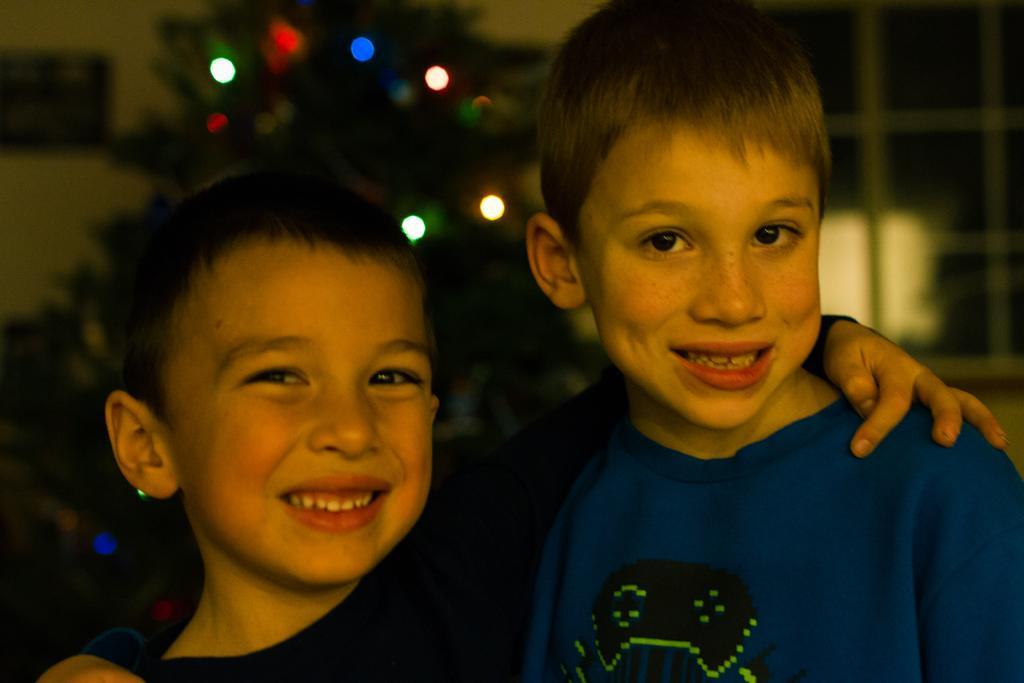Please provide a concise description of this image. In this image we can see two boys standing and smiling, behind them, we can see a tree with decorative lights and in the background we can see the buildings. 